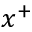<formula> <loc_0><loc_0><loc_500><loc_500>x ^ { + }</formula> 